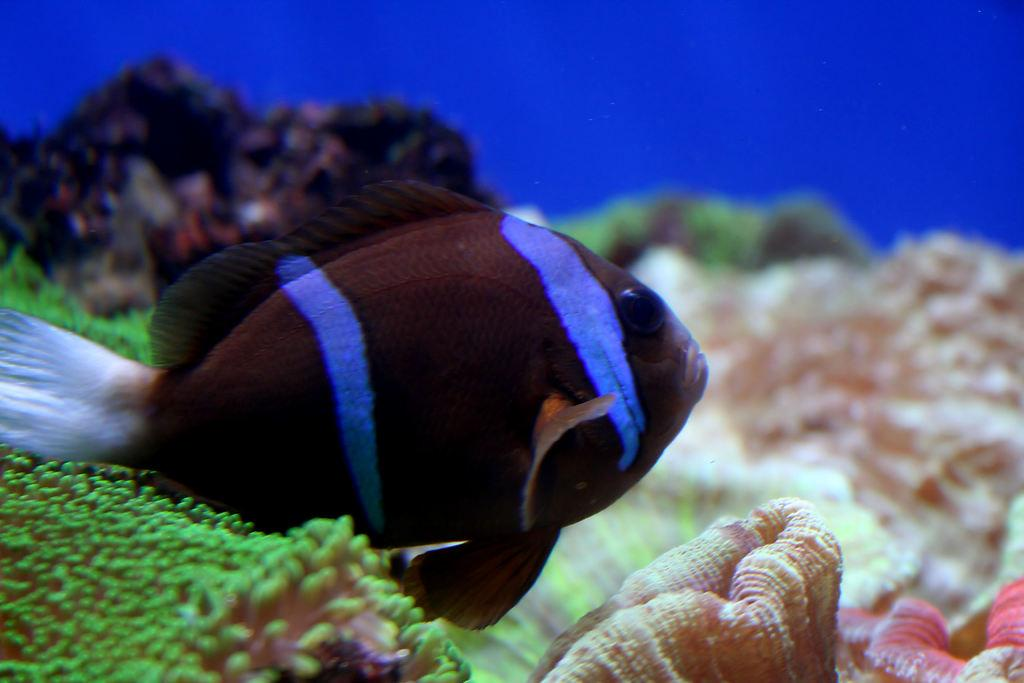What type of environment is depicted in the image? The image is of an aquarium. What type of animal can be seen in the aquarium? There is a fish in the aquarium. What other elements are present in the aquarium besides the fish? There are aquatic plants and shells in the aquarium. What type of juice is being served in the image? There is no juice being served in the image; it is a picture of an aquarium. Can you see anyone running in the image? There is no one running in the image; it is a picture of an aquarium with fish, aquatic plants, and shells. 